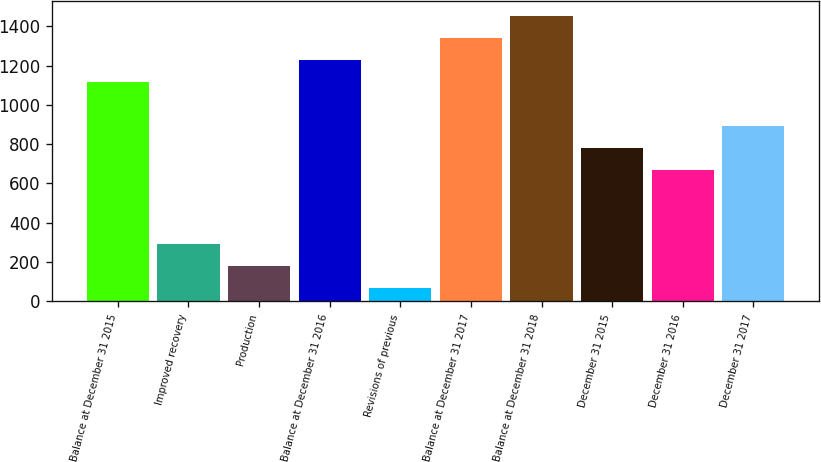Convert chart to OTSL. <chart><loc_0><loc_0><loc_500><loc_500><bar_chart><fcel>Balance at December 31 2015<fcel>Improved recovery<fcel>Production<fcel>Balance at December 31 2016<fcel>Revisions of previous<fcel>Balance at December 31 2017<fcel>Balance at December 31 2018<fcel>December 31 2015<fcel>December 31 2016<fcel>December 31 2017<nl><fcel>1118<fcel>290<fcel>178<fcel>1230<fcel>66<fcel>1342<fcel>1454<fcel>782<fcel>670<fcel>894<nl></chart> 